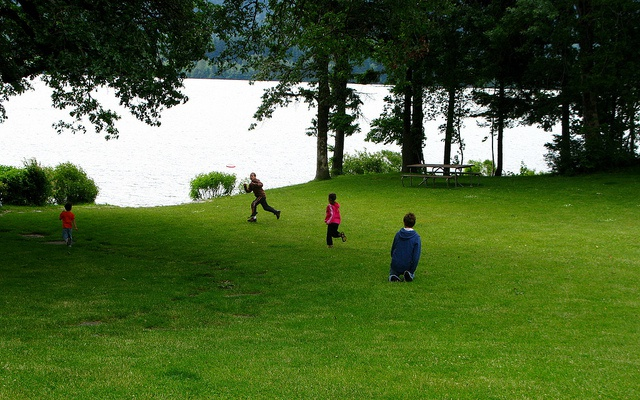Describe the objects in this image and their specific colors. I can see people in black, navy, darkgreen, and blue tones, people in black, darkgreen, olive, and maroon tones, people in black, brown, and maroon tones, people in black, maroon, and darkgreen tones, and bench in black, darkgreen, and gray tones in this image. 